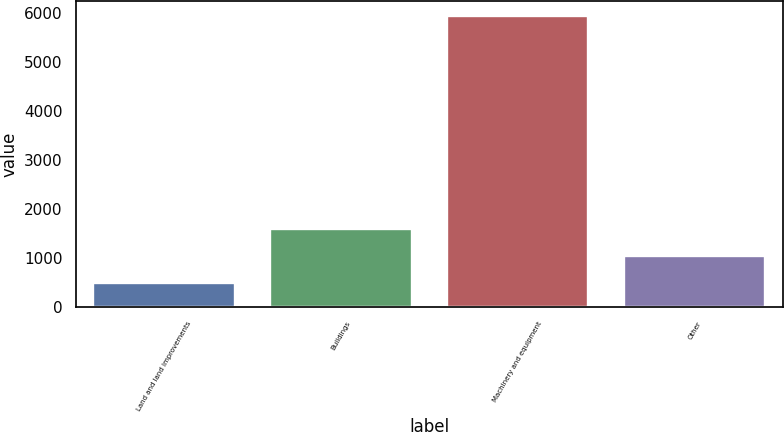Convert chart to OTSL. <chart><loc_0><loc_0><loc_500><loc_500><bar_chart><fcel>Land and land improvements<fcel>Buildings<fcel>Machinery and equipment<fcel>Other<nl><fcel>504<fcel>1593.6<fcel>5952<fcel>1048.8<nl></chart> 